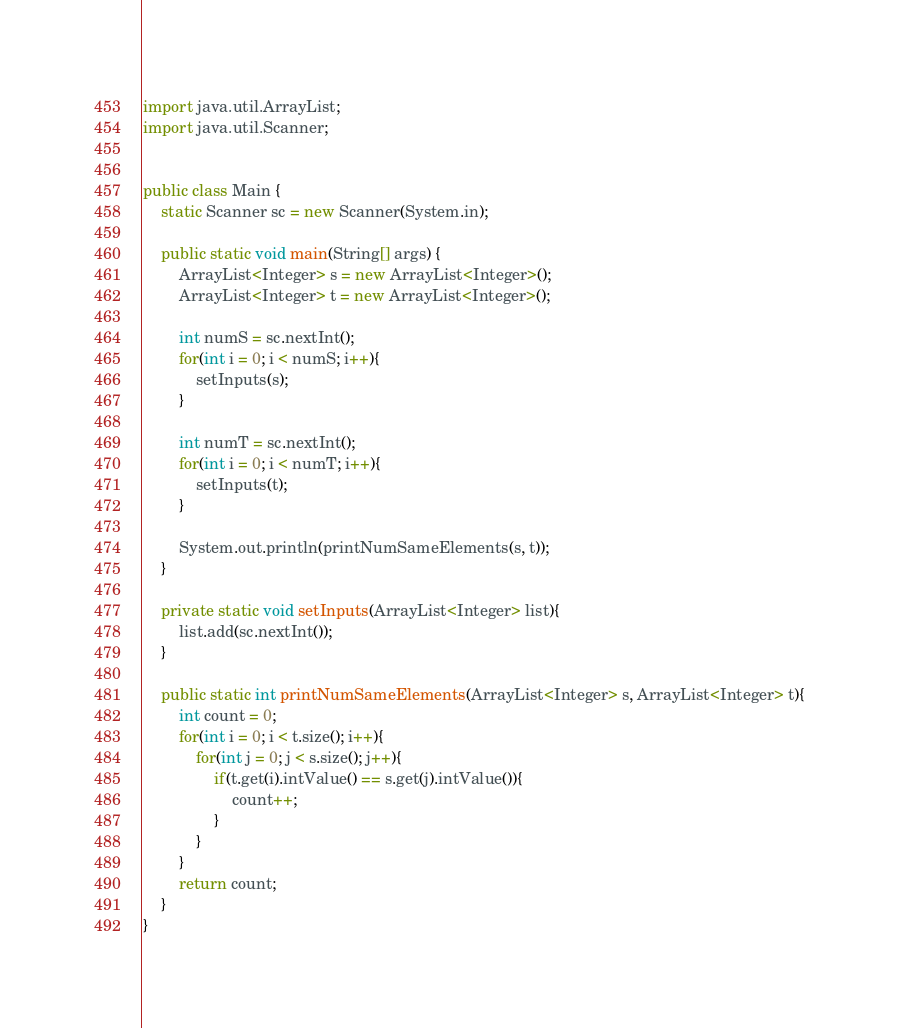Convert code to text. <code><loc_0><loc_0><loc_500><loc_500><_Java_>import java.util.ArrayList;
import java.util.Scanner;


public class Main {
	static Scanner sc = new Scanner(System.in);
	
	public static void main(String[] args) {
		ArrayList<Integer> s = new ArrayList<Integer>();
		ArrayList<Integer> t = new ArrayList<Integer>();
		
		int numS = sc.nextInt();
		for(int i = 0; i < numS; i++){
			setInputs(s);
		}
		
		int numT = sc.nextInt();
		for(int i = 0; i < numT; i++){
			setInputs(t);
		}
		
		System.out.println(printNumSameElements(s, t));
	}
	
	private static void setInputs(ArrayList<Integer> list){
		list.add(sc.nextInt());
	}
	
	public static int printNumSameElements(ArrayList<Integer> s, ArrayList<Integer> t){
		int count = 0;
		for(int i = 0; i < t.size(); i++){
			for(int j = 0; j < s.size(); j++){
				if(t.get(i).intValue() == s.get(j).intValue()){
					count++;
				}
			}
		}
		return count;
	}
}</code> 